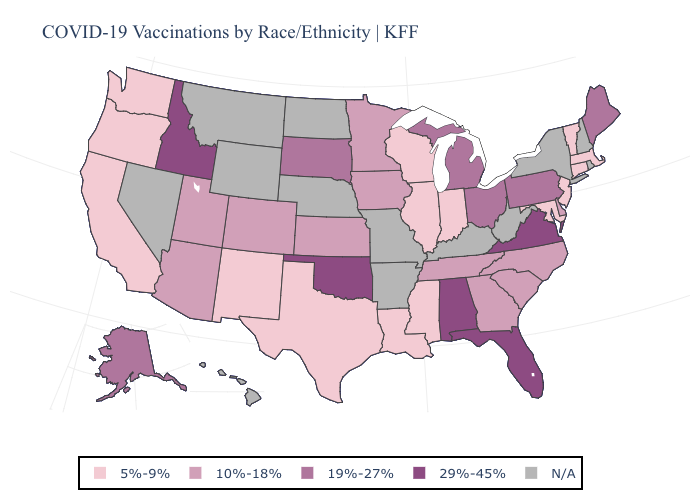Among the states that border North Dakota , which have the lowest value?
Give a very brief answer. Minnesota. What is the value of California?
Be succinct. 5%-9%. What is the lowest value in the South?
Keep it brief. 5%-9%. What is the highest value in the West ?
Answer briefly. 29%-45%. What is the value of New York?
Short answer required. N/A. What is the value of Nebraska?
Short answer required. N/A. Which states have the lowest value in the MidWest?
Be succinct. Illinois, Indiana, Wisconsin. How many symbols are there in the legend?
Quick response, please. 5. Which states have the lowest value in the MidWest?
Quick response, please. Illinois, Indiana, Wisconsin. What is the value of Connecticut?
Be succinct. 5%-9%. Name the states that have a value in the range N/A?
Answer briefly. Arkansas, Hawaii, Kentucky, Missouri, Montana, Nebraska, Nevada, New Hampshire, New York, North Dakota, Rhode Island, West Virginia, Wyoming. What is the lowest value in the USA?
Concise answer only. 5%-9%. What is the value of Minnesota?
Give a very brief answer. 10%-18%. 